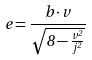<formula> <loc_0><loc_0><loc_500><loc_500>e = \frac { b \cdot v } { \sqrt { 8 - \frac { v ^ { 2 } } { j ^ { 2 } } } }</formula> 